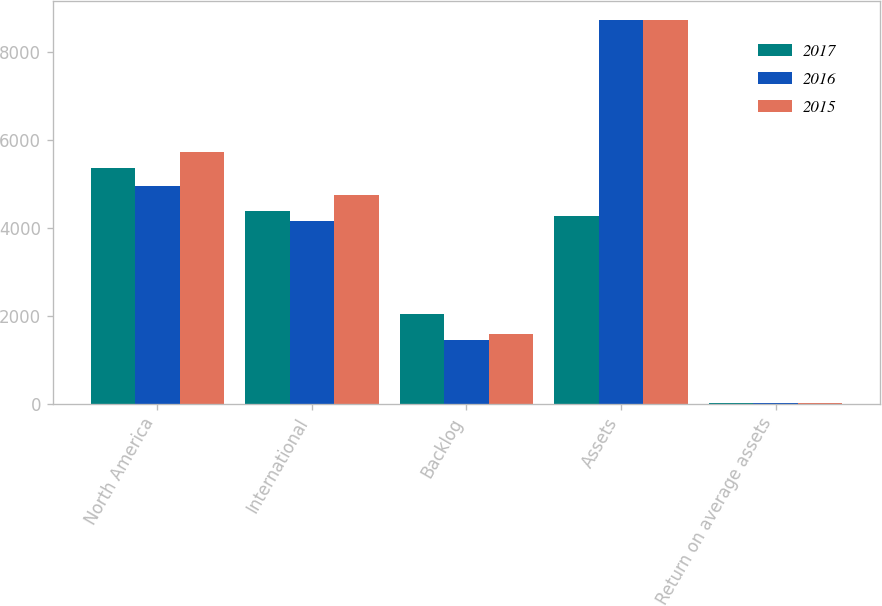<chart> <loc_0><loc_0><loc_500><loc_500><stacked_bar_chart><ecel><fcel>North America<fcel>International<fcel>Backlog<fcel>Assets<fcel>Return on average assets<nl><fcel>2017<fcel>5367<fcel>4378<fcel>2041<fcel>4261.5<fcel>13.1<nl><fcel>2016<fcel>4955<fcel>4145<fcel>1455<fcel>8729<fcel>14.2<nl><fcel>2015<fcel>5716<fcel>4741<fcel>1586<fcel>8735<fcel>16.9<nl></chart> 